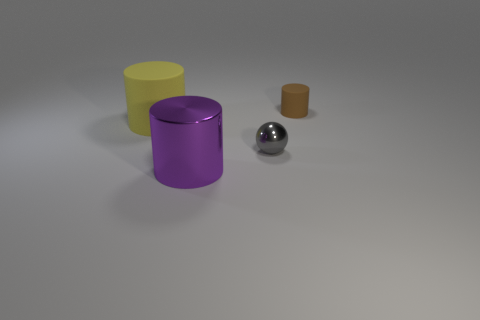The yellow matte cylinder has what size?
Ensure brevity in your answer.  Large. Are there any tiny purple cylinders?
Make the answer very short. No. Is the number of small gray objects that are on the right side of the big purple cylinder greater than the number of balls that are behind the big yellow cylinder?
Offer a terse response. Yes. There is a cylinder that is both behind the purple cylinder and to the left of the tiny gray object; what material is it made of?
Keep it short and to the point. Rubber. Does the brown matte thing have the same shape as the big rubber thing?
Keep it short and to the point. Yes. There is a small rubber cylinder; what number of big yellow rubber things are to the left of it?
Offer a terse response. 1. Is the size of the object that is behind the yellow object the same as the large yellow matte cylinder?
Offer a very short reply. No. What color is the other matte thing that is the same shape as the brown rubber object?
Ensure brevity in your answer.  Yellow. Is there any other thing that has the same shape as the small brown object?
Make the answer very short. Yes. What shape is the small thing in front of the brown matte cylinder?
Provide a succinct answer. Sphere. 